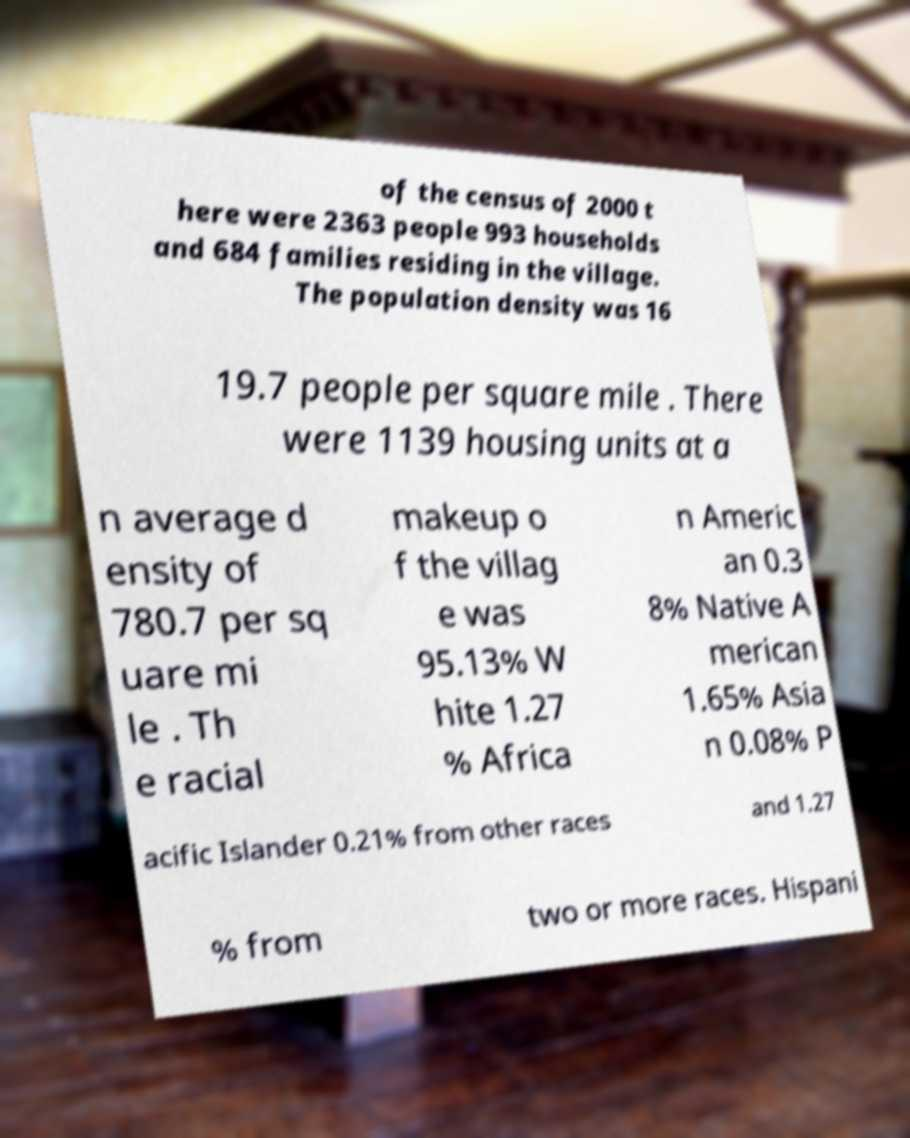Could you extract and type out the text from this image? of the census of 2000 t here were 2363 people 993 households and 684 families residing in the village. The population density was 16 19.7 people per square mile . There were 1139 housing units at a n average d ensity of 780.7 per sq uare mi le . Th e racial makeup o f the villag e was 95.13% W hite 1.27 % Africa n Americ an 0.3 8% Native A merican 1.65% Asia n 0.08% P acific Islander 0.21% from other races and 1.27 % from two or more races. Hispani 